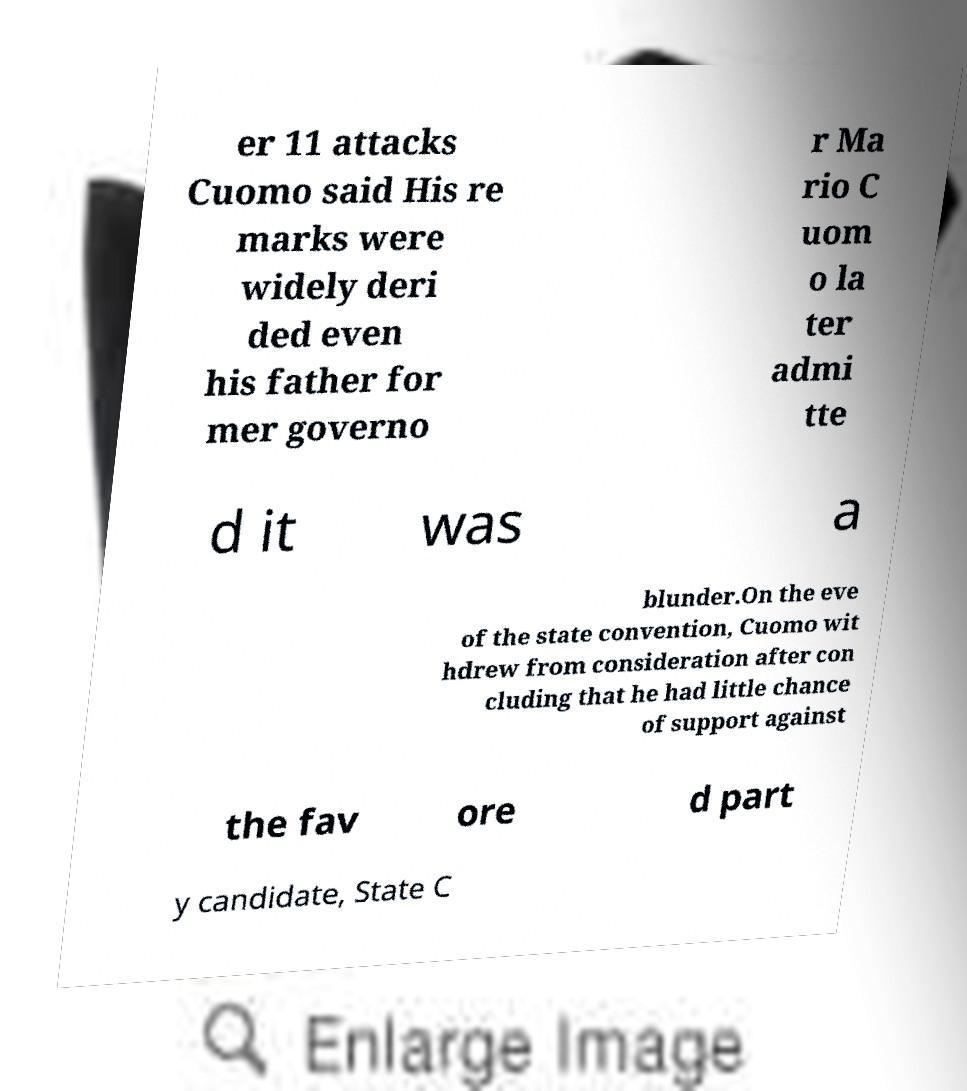Could you extract and type out the text from this image? er 11 attacks Cuomo said His re marks were widely deri ded even his father for mer governo r Ma rio C uom o la ter admi tte d it was a blunder.On the eve of the state convention, Cuomo wit hdrew from consideration after con cluding that he had little chance of support against the fav ore d part y candidate, State C 